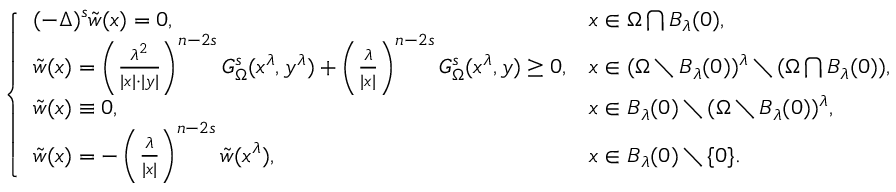<formula> <loc_0><loc_0><loc_500><loc_500>\left \{ \begin{array} { l l } { ( - \Delta ) ^ { s } \tilde { w } ( x ) = 0 , \quad } & { x \in \Omega \bigcap B _ { \lambda } ( 0 ) , } \\ { \tilde { w } ( x ) = \left ( \frac { \lambda ^ { 2 } } { | x | \cdot | y | } \right ) ^ { n - 2 s } G _ { \Omega } ^ { s } ( x ^ { \lambda } , y ^ { \lambda } ) + \left ( \frac { \lambda } { | x | } \right ) ^ { n - 2 s } G _ { \Omega } ^ { s } ( x ^ { \lambda } , y ) \geq 0 , } & { x \in ( \Omega \ B _ { \lambda } ( 0 ) ) ^ { \lambda } \ ( \Omega \bigcap B _ { \lambda } ( 0 ) ) , } \\ { \tilde { w } ( x ) \equiv 0 , } & { x \in B _ { \lambda } ( 0 ) \ ( \Omega \ B _ { \lambda } ( 0 ) ) ^ { \lambda } , } \\ { \tilde { w } ( x ) = - \left ( \frac { \lambda } { | x | } \right ) ^ { n - 2 s } \tilde { w } ( x ^ { \lambda } ) , } & { x \in B _ { \lambda } ( 0 ) \ \{ 0 \} . } \end{array}</formula> 